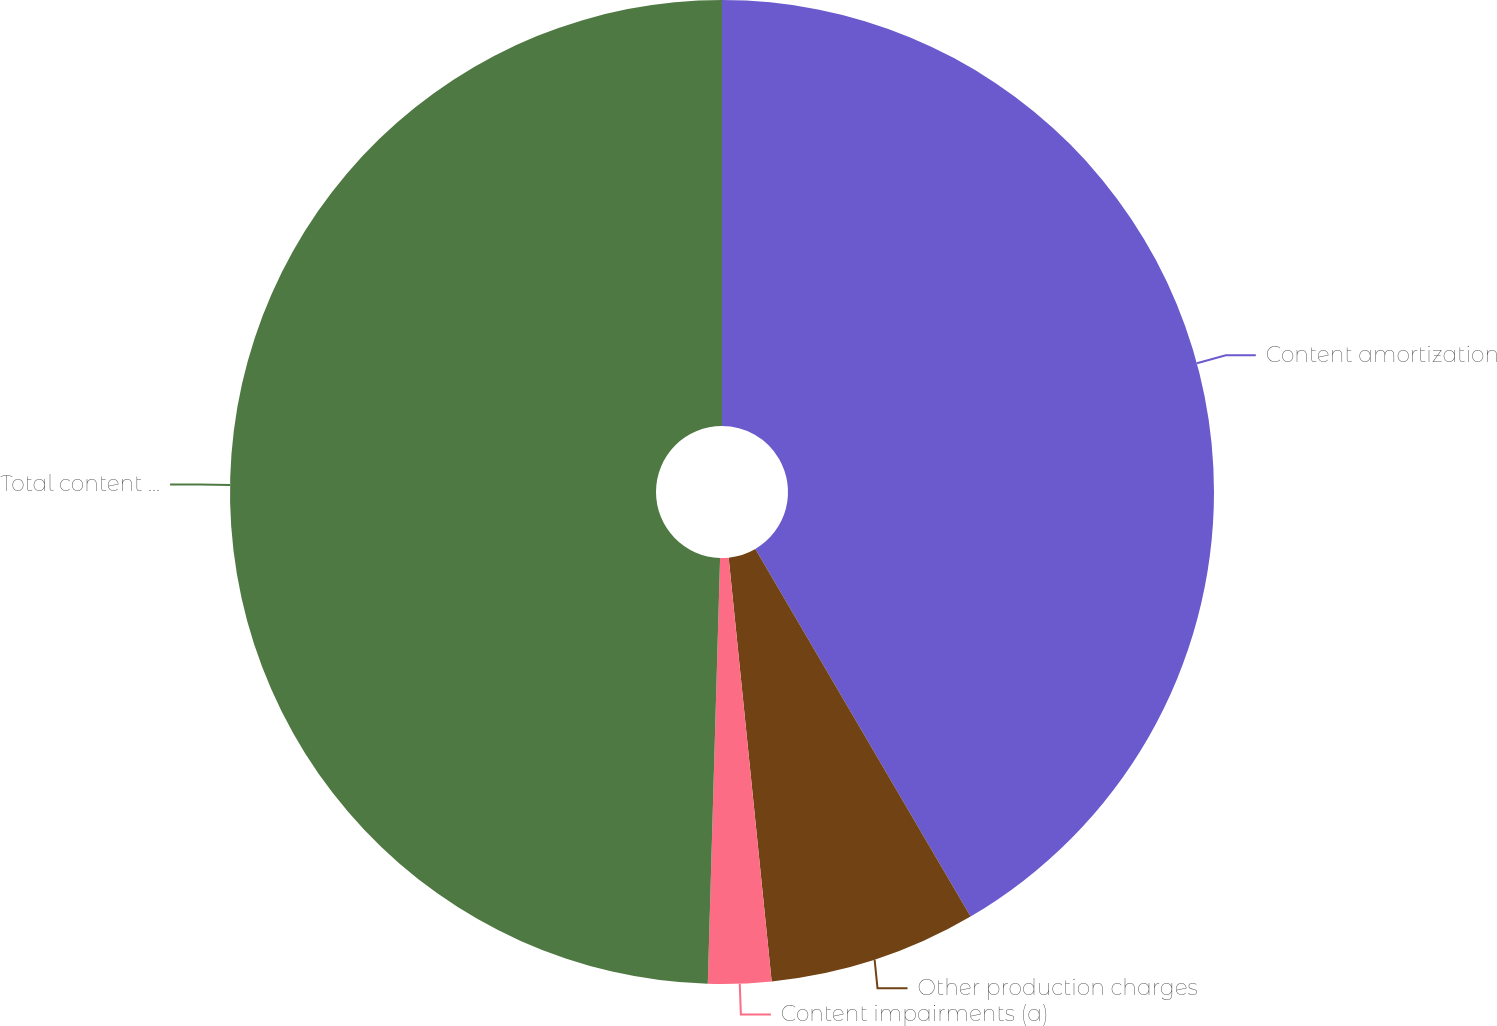Convert chart. <chart><loc_0><loc_0><loc_500><loc_500><pie_chart><fcel>Content amortization<fcel>Other production charges<fcel>Content impairments (a)<fcel>Total content expense<nl><fcel>41.57%<fcel>6.82%<fcel>2.07%<fcel>49.54%<nl></chart> 